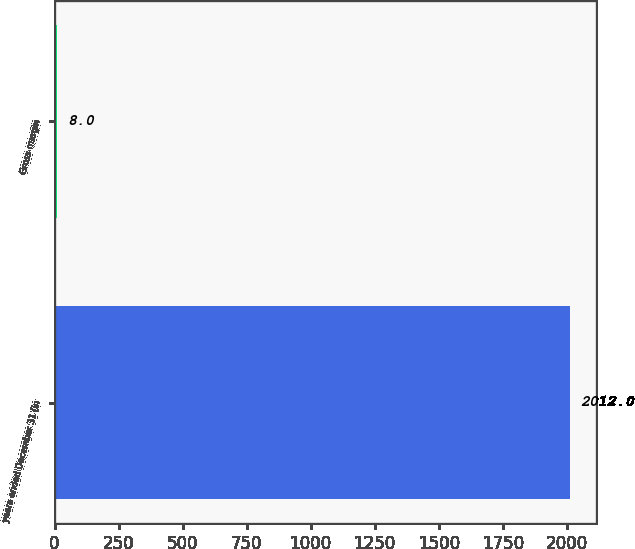Convert chart to OTSL. <chart><loc_0><loc_0><loc_500><loc_500><bar_chart><fcel>years ended December 31 (in<fcel>Gross margin<nl><fcel>2012<fcel>8<nl></chart> 